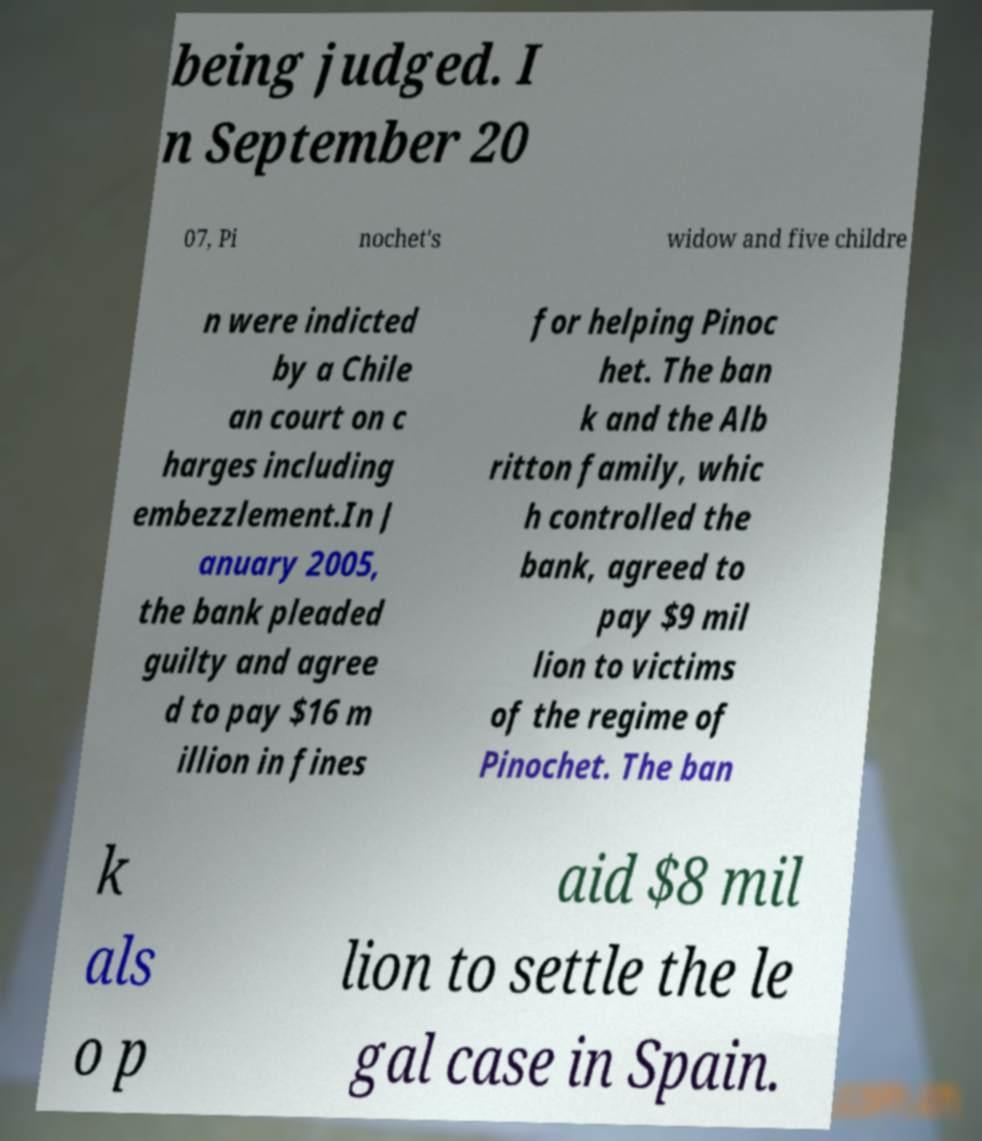For documentation purposes, I need the text within this image transcribed. Could you provide that? being judged. I n September 20 07, Pi nochet's widow and five childre n were indicted by a Chile an court on c harges including embezzlement.In J anuary 2005, the bank pleaded guilty and agree d to pay $16 m illion in fines for helping Pinoc het. The ban k and the Alb ritton family, whic h controlled the bank, agreed to pay $9 mil lion to victims of the regime of Pinochet. The ban k als o p aid $8 mil lion to settle the le gal case in Spain. 